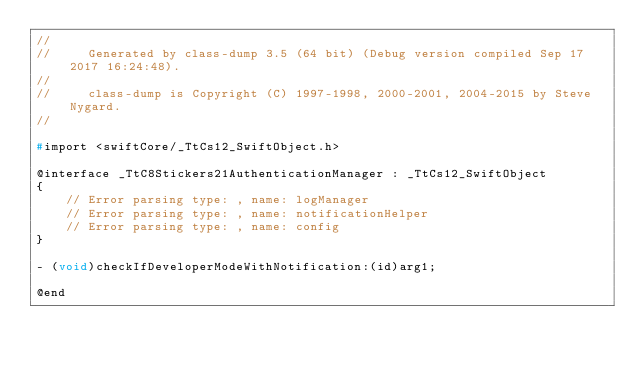Convert code to text. <code><loc_0><loc_0><loc_500><loc_500><_C_>//
//     Generated by class-dump 3.5 (64 bit) (Debug version compiled Sep 17 2017 16:24:48).
//
//     class-dump is Copyright (C) 1997-1998, 2000-2001, 2004-2015 by Steve Nygard.
//

#import <swiftCore/_TtCs12_SwiftObject.h>

@interface _TtC8Stickers21AuthenticationManager : _TtCs12_SwiftObject
{
    // Error parsing type: , name: logManager
    // Error parsing type: , name: notificationHelper
    // Error parsing type: , name: config
}

- (void)checkIfDeveloperModeWithNotification:(id)arg1;

@end

</code> 